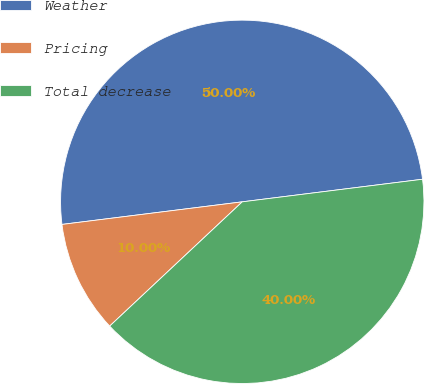Convert chart. <chart><loc_0><loc_0><loc_500><loc_500><pie_chart><fcel>Weather<fcel>Pricing<fcel>Total decrease<nl><fcel>50.0%<fcel>10.0%<fcel>40.0%<nl></chart> 